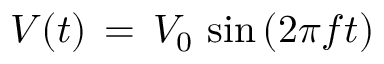<formula> <loc_0><loc_0><loc_500><loc_500>V ( t ) \, = \, V _ { 0 } \, \sin { ( 2 \pi f t } )</formula> 